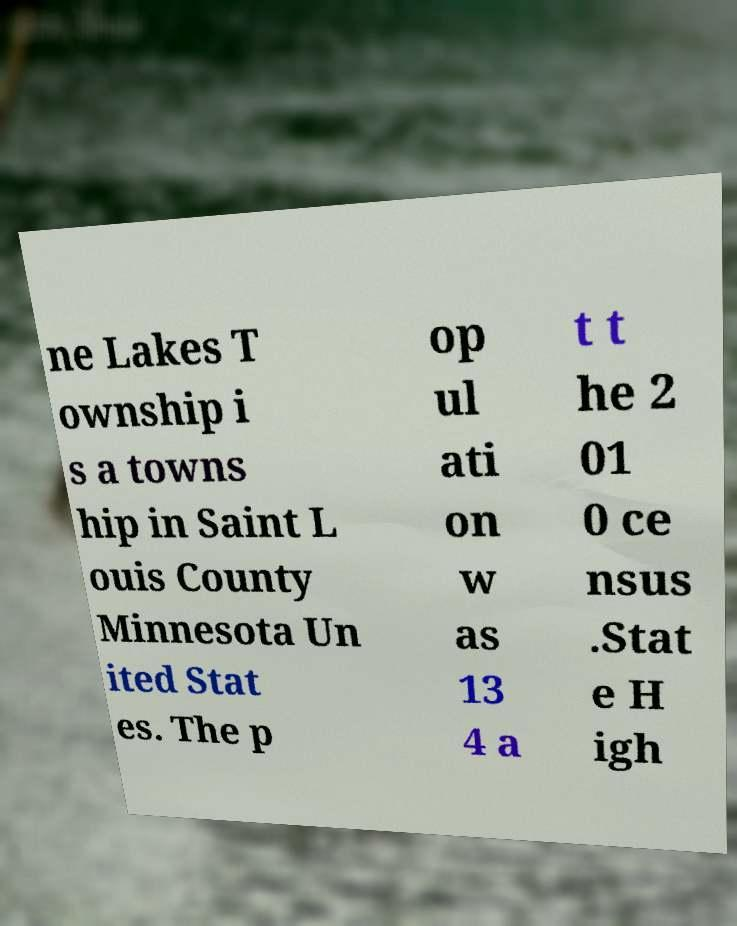Can you accurately transcribe the text from the provided image for me? ne Lakes T ownship i s a towns hip in Saint L ouis County Minnesota Un ited Stat es. The p op ul ati on w as 13 4 a t t he 2 01 0 ce nsus .Stat e H igh 